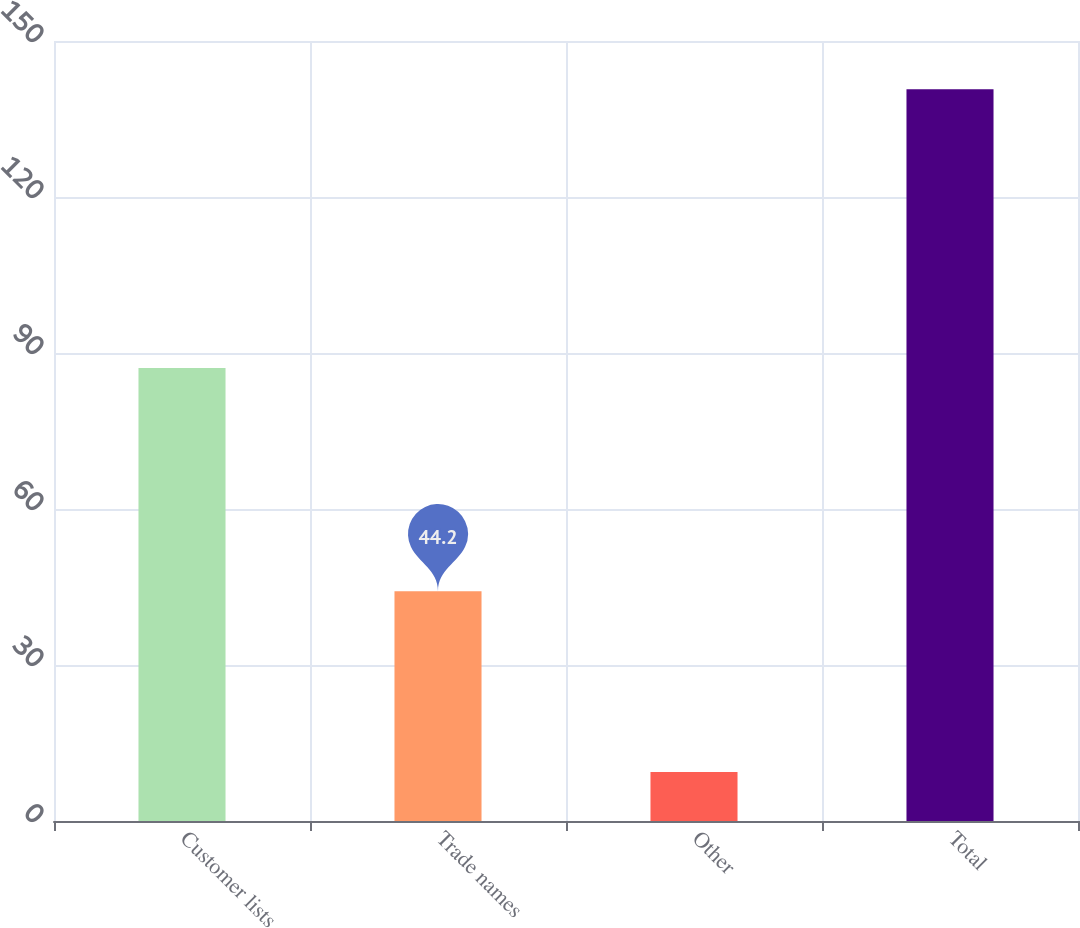Convert chart. <chart><loc_0><loc_0><loc_500><loc_500><bar_chart><fcel>Customer lists<fcel>Trade names<fcel>Other<fcel>Total<nl><fcel>87.1<fcel>44.2<fcel>9.4<fcel>140.7<nl></chart> 